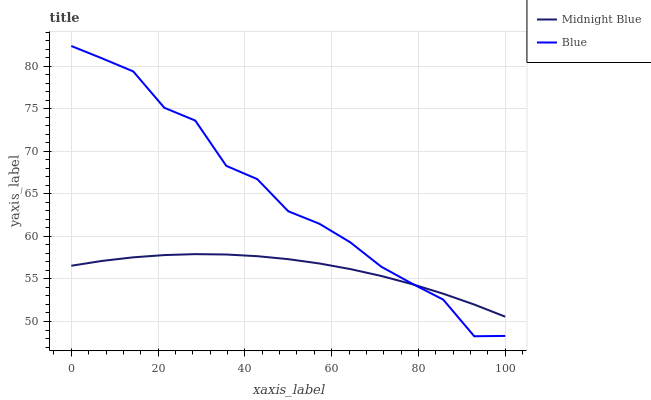Does Midnight Blue have the minimum area under the curve?
Answer yes or no. Yes. Does Blue have the maximum area under the curve?
Answer yes or no. Yes. Does Midnight Blue have the maximum area under the curve?
Answer yes or no. No. Is Midnight Blue the smoothest?
Answer yes or no. Yes. Is Blue the roughest?
Answer yes or no. Yes. Is Midnight Blue the roughest?
Answer yes or no. No. Does Blue have the lowest value?
Answer yes or no. Yes. Does Midnight Blue have the lowest value?
Answer yes or no. No. Does Blue have the highest value?
Answer yes or no. Yes. Does Midnight Blue have the highest value?
Answer yes or no. No. Does Blue intersect Midnight Blue?
Answer yes or no. Yes. Is Blue less than Midnight Blue?
Answer yes or no. No. Is Blue greater than Midnight Blue?
Answer yes or no. No. 